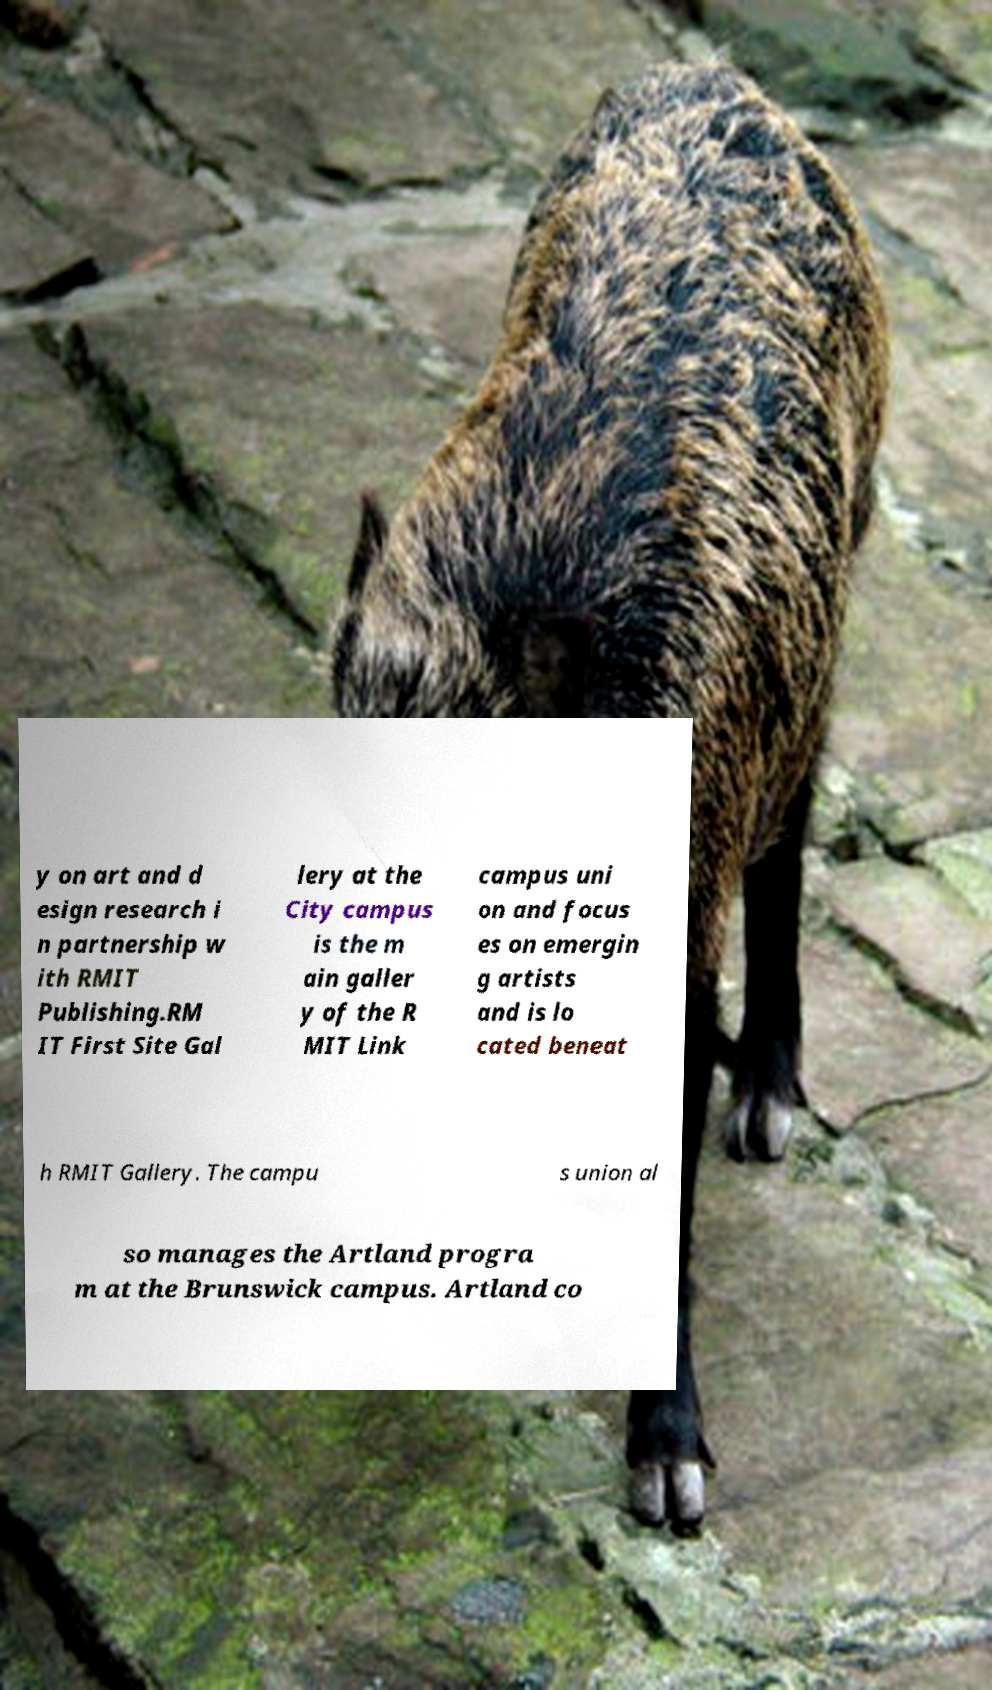What messages or text are displayed in this image? I need them in a readable, typed format. y on art and d esign research i n partnership w ith RMIT Publishing.RM IT First Site Gal lery at the City campus is the m ain galler y of the R MIT Link campus uni on and focus es on emergin g artists and is lo cated beneat h RMIT Gallery. The campu s union al so manages the Artland progra m at the Brunswick campus. Artland co 